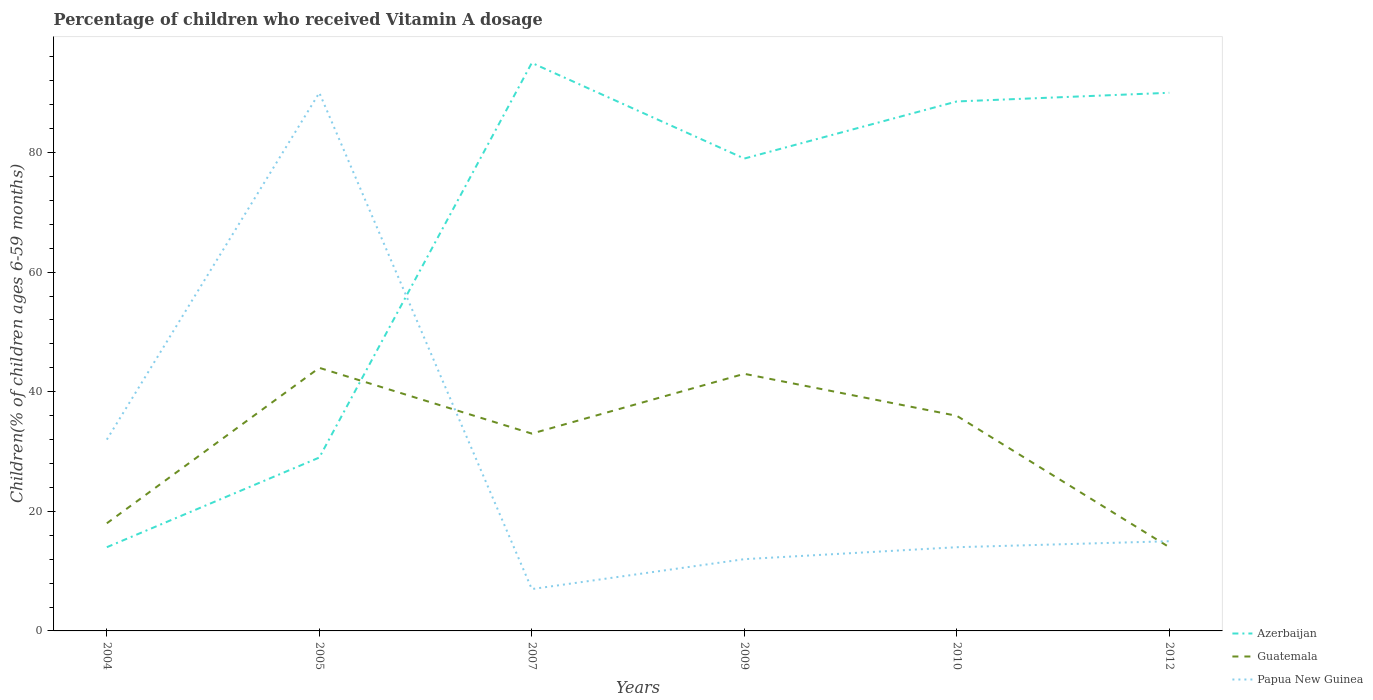How many different coloured lines are there?
Provide a succinct answer. 3. In which year was the percentage of children who received Vitamin A dosage in Guatemala maximum?
Provide a succinct answer. 2012. What is the difference between the highest and the lowest percentage of children who received Vitamin A dosage in Papua New Guinea?
Your response must be concise. 2. How many lines are there?
Provide a succinct answer. 3. What is the difference between two consecutive major ticks on the Y-axis?
Ensure brevity in your answer.  20. Does the graph contain any zero values?
Give a very brief answer. No. Where does the legend appear in the graph?
Provide a succinct answer. Bottom right. How many legend labels are there?
Provide a short and direct response. 3. What is the title of the graph?
Offer a terse response. Percentage of children who received Vitamin A dosage. What is the label or title of the X-axis?
Your answer should be compact. Years. What is the label or title of the Y-axis?
Ensure brevity in your answer.  Children(% of children ages 6-59 months). What is the Children(% of children ages 6-59 months) of Azerbaijan in 2004?
Your answer should be very brief. 14. What is the Children(% of children ages 6-59 months) of Guatemala in 2004?
Make the answer very short. 18. What is the Children(% of children ages 6-59 months) of Papua New Guinea in 2004?
Give a very brief answer. 32. What is the Children(% of children ages 6-59 months) in Papua New Guinea in 2005?
Provide a succinct answer. 90. What is the Children(% of children ages 6-59 months) in Azerbaijan in 2007?
Offer a very short reply. 95. What is the Children(% of children ages 6-59 months) in Guatemala in 2007?
Your response must be concise. 33. What is the Children(% of children ages 6-59 months) in Papua New Guinea in 2007?
Ensure brevity in your answer.  7. What is the Children(% of children ages 6-59 months) of Azerbaijan in 2009?
Keep it short and to the point. 79. What is the Children(% of children ages 6-59 months) in Papua New Guinea in 2009?
Your response must be concise. 12. What is the Children(% of children ages 6-59 months) of Azerbaijan in 2010?
Ensure brevity in your answer.  88.55. What is the Children(% of children ages 6-59 months) of Guatemala in 2010?
Keep it short and to the point. 35.98. What is the Children(% of children ages 6-59 months) in Papua New Guinea in 2010?
Your answer should be very brief. 14. What is the Children(% of children ages 6-59 months) in Guatemala in 2012?
Keep it short and to the point. 14. What is the Children(% of children ages 6-59 months) in Papua New Guinea in 2012?
Keep it short and to the point. 15. Across all years, what is the maximum Children(% of children ages 6-59 months) in Azerbaijan?
Offer a terse response. 95. Across all years, what is the minimum Children(% of children ages 6-59 months) of Guatemala?
Make the answer very short. 14. Across all years, what is the minimum Children(% of children ages 6-59 months) in Papua New Guinea?
Provide a succinct answer. 7. What is the total Children(% of children ages 6-59 months) of Azerbaijan in the graph?
Your answer should be compact. 395.55. What is the total Children(% of children ages 6-59 months) of Guatemala in the graph?
Your answer should be very brief. 187.98. What is the total Children(% of children ages 6-59 months) of Papua New Guinea in the graph?
Ensure brevity in your answer.  170. What is the difference between the Children(% of children ages 6-59 months) in Guatemala in 2004 and that in 2005?
Your answer should be very brief. -26. What is the difference between the Children(% of children ages 6-59 months) of Papua New Guinea in 2004 and that in 2005?
Keep it short and to the point. -58. What is the difference between the Children(% of children ages 6-59 months) in Azerbaijan in 2004 and that in 2007?
Make the answer very short. -81. What is the difference between the Children(% of children ages 6-59 months) in Guatemala in 2004 and that in 2007?
Keep it short and to the point. -15. What is the difference between the Children(% of children ages 6-59 months) of Papua New Guinea in 2004 and that in 2007?
Provide a succinct answer. 25. What is the difference between the Children(% of children ages 6-59 months) in Azerbaijan in 2004 and that in 2009?
Offer a very short reply. -65. What is the difference between the Children(% of children ages 6-59 months) in Guatemala in 2004 and that in 2009?
Provide a succinct answer. -25. What is the difference between the Children(% of children ages 6-59 months) in Azerbaijan in 2004 and that in 2010?
Keep it short and to the point. -74.55. What is the difference between the Children(% of children ages 6-59 months) of Guatemala in 2004 and that in 2010?
Your answer should be compact. -17.98. What is the difference between the Children(% of children ages 6-59 months) in Papua New Guinea in 2004 and that in 2010?
Your response must be concise. 18. What is the difference between the Children(% of children ages 6-59 months) of Azerbaijan in 2004 and that in 2012?
Your answer should be compact. -76. What is the difference between the Children(% of children ages 6-59 months) of Papua New Guinea in 2004 and that in 2012?
Provide a succinct answer. 17. What is the difference between the Children(% of children ages 6-59 months) in Azerbaijan in 2005 and that in 2007?
Provide a short and direct response. -66. What is the difference between the Children(% of children ages 6-59 months) in Papua New Guinea in 2005 and that in 2007?
Provide a succinct answer. 83. What is the difference between the Children(% of children ages 6-59 months) in Azerbaijan in 2005 and that in 2009?
Your response must be concise. -50. What is the difference between the Children(% of children ages 6-59 months) in Guatemala in 2005 and that in 2009?
Make the answer very short. 1. What is the difference between the Children(% of children ages 6-59 months) in Azerbaijan in 2005 and that in 2010?
Ensure brevity in your answer.  -59.55. What is the difference between the Children(% of children ages 6-59 months) in Guatemala in 2005 and that in 2010?
Ensure brevity in your answer.  8.02. What is the difference between the Children(% of children ages 6-59 months) of Papua New Guinea in 2005 and that in 2010?
Keep it short and to the point. 76. What is the difference between the Children(% of children ages 6-59 months) of Azerbaijan in 2005 and that in 2012?
Your answer should be very brief. -61. What is the difference between the Children(% of children ages 6-59 months) in Papua New Guinea in 2005 and that in 2012?
Your answer should be very brief. 75. What is the difference between the Children(% of children ages 6-59 months) of Azerbaijan in 2007 and that in 2009?
Make the answer very short. 16. What is the difference between the Children(% of children ages 6-59 months) of Papua New Guinea in 2007 and that in 2009?
Ensure brevity in your answer.  -5. What is the difference between the Children(% of children ages 6-59 months) in Azerbaijan in 2007 and that in 2010?
Your answer should be very brief. 6.45. What is the difference between the Children(% of children ages 6-59 months) in Guatemala in 2007 and that in 2010?
Your answer should be compact. -2.98. What is the difference between the Children(% of children ages 6-59 months) in Papua New Guinea in 2007 and that in 2010?
Your answer should be very brief. -7. What is the difference between the Children(% of children ages 6-59 months) in Azerbaijan in 2007 and that in 2012?
Make the answer very short. 5. What is the difference between the Children(% of children ages 6-59 months) of Guatemala in 2007 and that in 2012?
Your response must be concise. 19. What is the difference between the Children(% of children ages 6-59 months) in Papua New Guinea in 2007 and that in 2012?
Offer a very short reply. -8. What is the difference between the Children(% of children ages 6-59 months) of Azerbaijan in 2009 and that in 2010?
Provide a succinct answer. -9.55. What is the difference between the Children(% of children ages 6-59 months) in Guatemala in 2009 and that in 2010?
Make the answer very short. 7.02. What is the difference between the Children(% of children ages 6-59 months) in Papua New Guinea in 2009 and that in 2010?
Keep it short and to the point. -2. What is the difference between the Children(% of children ages 6-59 months) in Azerbaijan in 2010 and that in 2012?
Keep it short and to the point. -1.45. What is the difference between the Children(% of children ages 6-59 months) of Guatemala in 2010 and that in 2012?
Your response must be concise. 21.98. What is the difference between the Children(% of children ages 6-59 months) of Azerbaijan in 2004 and the Children(% of children ages 6-59 months) of Papua New Guinea in 2005?
Offer a terse response. -76. What is the difference between the Children(% of children ages 6-59 months) in Guatemala in 2004 and the Children(% of children ages 6-59 months) in Papua New Guinea in 2005?
Your response must be concise. -72. What is the difference between the Children(% of children ages 6-59 months) of Azerbaijan in 2004 and the Children(% of children ages 6-59 months) of Guatemala in 2007?
Offer a very short reply. -19. What is the difference between the Children(% of children ages 6-59 months) of Guatemala in 2004 and the Children(% of children ages 6-59 months) of Papua New Guinea in 2007?
Your response must be concise. 11. What is the difference between the Children(% of children ages 6-59 months) in Azerbaijan in 2004 and the Children(% of children ages 6-59 months) in Guatemala in 2009?
Provide a succinct answer. -29. What is the difference between the Children(% of children ages 6-59 months) in Azerbaijan in 2004 and the Children(% of children ages 6-59 months) in Guatemala in 2010?
Offer a terse response. -21.98. What is the difference between the Children(% of children ages 6-59 months) of Guatemala in 2004 and the Children(% of children ages 6-59 months) of Papua New Guinea in 2010?
Offer a very short reply. 4. What is the difference between the Children(% of children ages 6-59 months) of Azerbaijan in 2004 and the Children(% of children ages 6-59 months) of Guatemala in 2012?
Give a very brief answer. 0. What is the difference between the Children(% of children ages 6-59 months) in Azerbaijan in 2005 and the Children(% of children ages 6-59 months) in Guatemala in 2007?
Your answer should be compact. -4. What is the difference between the Children(% of children ages 6-59 months) of Azerbaijan in 2005 and the Children(% of children ages 6-59 months) of Papua New Guinea in 2007?
Your answer should be compact. 22. What is the difference between the Children(% of children ages 6-59 months) of Azerbaijan in 2005 and the Children(% of children ages 6-59 months) of Guatemala in 2009?
Offer a very short reply. -14. What is the difference between the Children(% of children ages 6-59 months) in Azerbaijan in 2005 and the Children(% of children ages 6-59 months) in Papua New Guinea in 2009?
Give a very brief answer. 17. What is the difference between the Children(% of children ages 6-59 months) of Azerbaijan in 2005 and the Children(% of children ages 6-59 months) of Guatemala in 2010?
Make the answer very short. -6.98. What is the difference between the Children(% of children ages 6-59 months) of Azerbaijan in 2005 and the Children(% of children ages 6-59 months) of Guatemala in 2012?
Provide a short and direct response. 15. What is the difference between the Children(% of children ages 6-59 months) in Azerbaijan in 2005 and the Children(% of children ages 6-59 months) in Papua New Guinea in 2012?
Provide a succinct answer. 14. What is the difference between the Children(% of children ages 6-59 months) of Guatemala in 2005 and the Children(% of children ages 6-59 months) of Papua New Guinea in 2012?
Give a very brief answer. 29. What is the difference between the Children(% of children ages 6-59 months) of Azerbaijan in 2007 and the Children(% of children ages 6-59 months) of Papua New Guinea in 2009?
Keep it short and to the point. 83. What is the difference between the Children(% of children ages 6-59 months) in Azerbaijan in 2007 and the Children(% of children ages 6-59 months) in Guatemala in 2010?
Offer a very short reply. 59.02. What is the difference between the Children(% of children ages 6-59 months) in Azerbaijan in 2007 and the Children(% of children ages 6-59 months) in Papua New Guinea in 2010?
Provide a short and direct response. 81. What is the difference between the Children(% of children ages 6-59 months) of Azerbaijan in 2007 and the Children(% of children ages 6-59 months) of Guatemala in 2012?
Make the answer very short. 81. What is the difference between the Children(% of children ages 6-59 months) in Azerbaijan in 2007 and the Children(% of children ages 6-59 months) in Papua New Guinea in 2012?
Ensure brevity in your answer.  80. What is the difference between the Children(% of children ages 6-59 months) in Guatemala in 2007 and the Children(% of children ages 6-59 months) in Papua New Guinea in 2012?
Offer a very short reply. 18. What is the difference between the Children(% of children ages 6-59 months) in Azerbaijan in 2009 and the Children(% of children ages 6-59 months) in Guatemala in 2010?
Your answer should be very brief. 43.02. What is the difference between the Children(% of children ages 6-59 months) in Azerbaijan in 2009 and the Children(% of children ages 6-59 months) in Papua New Guinea in 2010?
Offer a very short reply. 65. What is the difference between the Children(% of children ages 6-59 months) in Azerbaijan in 2009 and the Children(% of children ages 6-59 months) in Guatemala in 2012?
Keep it short and to the point. 65. What is the difference between the Children(% of children ages 6-59 months) in Azerbaijan in 2009 and the Children(% of children ages 6-59 months) in Papua New Guinea in 2012?
Keep it short and to the point. 64. What is the difference between the Children(% of children ages 6-59 months) in Guatemala in 2009 and the Children(% of children ages 6-59 months) in Papua New Guinea in 2012?
Give a very brief answer. 28. What is the difference between the Children(% of children ages 6-59 months) in Azerbaijan in 2010 and the Children(% of children ages 6-59 months) in Guatemala in 2012?
Your answer should be compact. 74.55. What is the difference between the Children(% of children ages 6-59 months) in Azerbaijan in 2010 and the Children(% of children ages 6-59 months) in Papua New Guinea in 2012?
Ensure brevity in your answer.  73.55. What is the difference between the Children(% of children ages 6-59 months) of Guatemala in 2010 and the Children(% of children ages 6-59 months) of Papua New Guinea in 2012?
Make the answer very short. 20.98. What is the average Children(% of children ages 6-59 months) of Azerbaijan per year?
Keep it short and to the point. 65.92. What is the average Children(% of children ages 6-59 months) of Guatemala per year?
Ensure brevity in your answer.  31.33. What is the average Children(% of children ages 6-59 months) in Papua New Guinea per year?
Keep it short and to the point. 28.33. In the year 2004, what is the difference between the Children(% of children ages 6-59 months) in Azerbaijan and Children(% of children ages 6-59 months) in Guatemala?
Offer a very short reply. -4. In the year 2004, what is the difference between the Children(% of children ages 6-59 months) in Azerbaijan and Children(% of children ages 6-59 months) in Papua New Guinea?
Provide a succinct answer. -18. In the year 2004, what is the difference between the Children(% of children ages 6-59 months) in Guatemala and Children(% of children ages 6-59 months) in Papua New Guinea?
Provide a succinct answer. -14. In the year 2005, what is the difference between the Children(% of children ages 6-59 months) in Azerbaijan and Children(% of children ages 6-59 months) in Guatemala?
Offer a terse response. -15. In the year 2005, what is the difference between the Children(% of children ages 6-59 months) of Azerbaijan and Children(% of children ages 6-59 months) of Papua New Guinea?
Offer a terse response. -61. In the year 2005, what is the difference between the Children(% of children ages 6-59 months) of Guatemala and Children(% of children ages 6-59 months) of Papua New Guinea?
Your answer should be compact. -46. In the year 2007, what is the difference between the Children(% of children ages 6-59 months) of Azerbaijan and Children(% of children ages 6-59 months) of Papua New Guinea?
Offer a very short reply. 88. In the year 2009, what is the difference between the Children(% of children ages 6-59 months) of Azerbaijan and Children(% of children ages 6-59 months) of Guatemala?
Give a very brief answer. 36. In the year 2010, what is the difference between the Children(% of children ages 6-59 months) in Azerbaijan and Children(% of children ages 6-59 months) in Guatemala?
Give a very brief answer. 52.57. In the year 2010, what is the difference between the Children(% of children ages 6-59 months) in Azerbaijan and Children(% of children ages 6-59 months) in Papua New Guinea?
Ensure brevity in your answer.  74.55. In the year 2010, what is the difference between the Children(% of children ages 6-59 months) of Guatemala and Children(% of children ages 6-59 months) of Papua New Guinea?
Your response must be concise. 21.98. In the year 2012, what is the difference between the Children(% of children ages 6-59 months) of Azerbaijan and Children(% of children ages 6-59 months) of Guatemala?
Your answer should be compact. 76. In the year 2012, what is the difference between the Children(% of children ages 6-59 months) of Azerbaijan and Children(% of children ages 6-59 months) of Papua New Guinea?
Your answer should be very brief. 75. What is the ratio of the Children(% of children ages 6-59 months) of Azerbaijan in 2004 to that in 2005?
Your response must be concise. 0.48. What is the ratio of the Children(% of children ages 6-59 months) in Guatemala in 2004 to that in 2005?
Your answer should be compact. 0.41. What is the ratio of the Children(% of children ages 6-59 months) in Papua New Guinea in 2004 to that in 2005?
Provide a short and direct response. 0.36. What is the ratio of the Children(% of children ages 6-59 months) in Azerbaijan in 2004 to that in 2007?
Provide a succinct answer. 0.15. What is the ratio of the Children(% of children ages 6-59 months) of Guatemala in 2004 to that in 2007?
Offer a terse response. 0.55. What is the ratio of the Children(% of children ages 6-59 months) of Papua New Guinea in 2004 to that in 2007?
Your answer should be very brief. 4.57. What is the ratio of the Children(% of children ages 6-59 months) of Azerbaijan in 2004 to that in 2009?
Make the answer very short. 0.18. What is the ratio of the Children(% of children ages 6-59 months) in Guatemala in 2004 to that in 2009?
Offer a terse response. 0.42. What is the ratio of the Children(% of children ages 6-59 months) in Papua New Guinea in 2004 to that in 2009?
Provide a succinct answer. 2.67. What is the ratio of the Children(% of children ages 6-59 months) in Azerbaijan in 2004 to that in 2010?
Provide a short and direct response. 0.16. What is the ratio of the Children(% of children ages 6-59 months) of Guatemala in 2004 to that in 2010?
Provide a short and direct response. 0.5. What is the ratio of the Children(% of children ages 6-59 months) of Papua New Guinea in 2004 to that in 2010?
Give a very brief answer. 2.29. What is the ratio of the Children(% of children ages 6-59 months) in Azerbaijan in 2004 to that in 2012?
Your answer should be compact. 0.16. What is the ratio of the Children(% of children ages 6-59 months) in Guatemala in 2004 to that in 2012?
Offer a terse response. 1.29. What is the ratio of the Children(% of children ages 6-59 months) in Papua New Guinea in 2004 to that in 2012?
Offer a terse response. 2.13. What is the ratio of the Children(% of children ages 6-59 months) in Azerbaijan in 2005 to that in 2007?
Offer a terse response. 0.31. What is the ratio of the Children(% of children ages 6-59 months) in Guatemala in 2005 to that in 2007?
Offer a terse response. 1.33. What is the ratio of the Children(% of children ages 6-59 months) of Papua New Guinea in 2005 to that in 2007?
Keep it short and to the point. 12.86. What is the ratio of the Children(% of children ages 6-59 months) in Azerbaijan in 2005 to that in 2009?
Your response must be concise. 0.37. What is the ratio of the Children(% of children ages 6-59 months) in Guatemala in 2005 to that in 2009?
Your answer should be very brief. 1.02. What is the ratio of the Children(% of children ages 6-59 months) of Azerbaijan in 2005 to that in 2010?
Provide a succinct answer. 0.33. What is the ratio of the Children(% of children ages 6-59 months) of Guatemala in 2005 to that in 2010?
Your answer should be very brief. 1.22. What is the ratio of the Children(% of children ages 6-59 months) of Papua New Guinea in 2005 to that in 2010?
Ensure brevity in your answer.  6.43. What is the ratio of the Children(% of children ages 6-59 months) in Azerbaijan in 2005 to that in 2012?
Your response must be concise. 0.32. What is the ratio of the Children(% of children ages 6-59 months) of Guatemala in 2005 to that in 2012?
Keep it short and to the point. 3.14. What is the ratio of the Children(% of children ages 6-59 months) of Azerbaijan in 2007 to that in 2009?
Your answer should be compact. 1.2. What is the ratio of the Children(% of children ages 6-59 months) of Guatemala in 2007 to that in 2009?
Your answer should be compact. 0.77. What is the ratio of the Children(% of children ages 6-59 months) in Papua New Guinea in 2007 to that in 2009?
Provide a succinct answer. 0.58. What is the ratio of the Children(% of children ages 6-59 months) in Azerbaijan in 2007 to that in 2010?
Your response must be concise. 1.07. What is the ratio of the Children(% of children ages 6-59 months) in Guatemala in 2007 to that in 2010?
Provide a succinct answer. 0.92. What is the ratio of the Children(% of children ages 6-59 months) of Azerbaijan in 2007 to that in 2012?
Make the answer very short. 1.06. What is the ratio of the Children(% of children ages 6-59 months) of Guatemala in 2007 to that in 2012?
Your answer should be very brief. 2.36. What is the ratio of the Children(% of children ages 6-59 months) of Papua New Guinea in 2007 to that in 2012?
Your response must be concise. 0.47. What is the ratio of the Children(% of children ages 6-59 months) in Azerbaijan in 2009 to that in 2010?
Make the answer very short. 0.89. What is the ratio of the Children(% of children ages 6-59 months) of Guatemala in 2009 to that in 2010?
Your answer should be very brief. 1.2. What is the ratio of the Children(% of children ages 6-59 months) in Papua New Guinea in 2009 to that in 2010?
Offer a very short reply. 0.86. What is the ratio of the Children(% of children ages 6-59 months) in Azerbaijan in 2009 to that in 2012?
Give a very brief answer. 0.88. What is the ratio of the Children(% of children ages 6-59 months) of Guatemala in 2009 to that in 2012?
Provide a short and direct response. 3.07. What is the ratio of the Children(% of children ages 6-59 months) in Azerbaijan in 2010 to that in 2012?
Your answer should be compact. 0.98. What is the ratio of the Children(% of children ages 6-59 months) of Guatemala in 2010 to that in 2012?
Ensure brevity in your answer.  2.57. What is the difference between the highest and the second highest Children(% of children ages 6-59 months) of Azerbaijan?
Keep it short and to the point. 5. What is the difference between the highest and the second highest Children(% of children ages 6-59 months) of Guatemala?
Offer a very short reply. 1. What is the difference between the highest and the second highest Children(% of children ages 6-59 months) in Papua New Guinea?
Offer a very short reply. 58. What is the difference between the highest and the lowest Children(% of children ages 6-59 months) in Azerbaijan?
Offer a terse response. 81. 